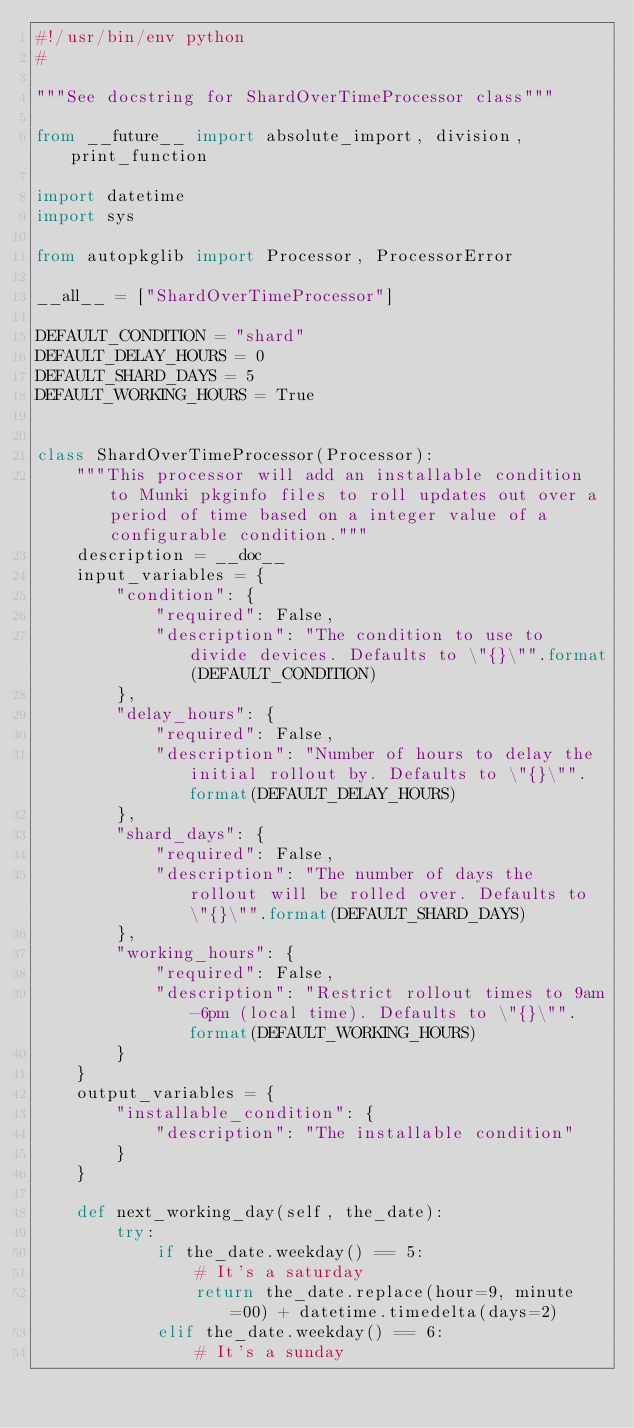Convert code to text. <code><loc_0><loc_0><loc_500><loc_500><_Python_>#!/usr/bin/env python
#

"""See docstring for ShardOverTimeProcessor class"""

from __future__ import absolute_import, division, print_function

import datetime
import sys

from autopkglib import Processor, ProcessorError

__all__ = ["ShardOverTimeProcessor"]

DEFAULT_CONDITION = "shard"
DEFAULT_DELAY_HOURS = 0
DEFAULT_SHARD_DAYS = 5
DEFAULT_WORKING_HOURS = True


class ShardOverTimeProcessor(Processor):
    """This processor will add an installable condition to Munki pkginfo files to roll updates out over a period of time based on a integer value of a configurable condition."""
    description = __doc__
    input_variables = {
        "condition": {
            "required": False,
            "description": "The condition to use to divide devices. Defaults to \"{}\"".format(DEFAULT_CONDITION)
        },
        "delay_hours": {
            "required": False,
            "description": "Number of hours to delay the initial rollout by. Defaults to \"{}\"".format(DEFAULT_DELAY_HOURS)
        },
        "shard_days": {
            "required": False,
            "description": "The number of days the rollout will be rolled over. Defaults to \"{}\"".format(DEFAULT_SHARD_DAYS)
        },
        "working_hours": {
            "required": False,
            "description": "Restrict rollout times to 9am-6pm (local time). Defaults to \"{}\"".format(DEFAULT_WORKING_HOURS)
        }
    }
    output_variables = {
        "installable_condition": {
            "description": "The installable condition"
        }
    }

    def next_working_day(self, the_date):
        try:
            if the_date.weekday() == 5:
                # It's a saturday
                return the_date.replace(hour=9, minute=00) + datetime.timedelta(days=2)
            elif the_date.weekday() == 6:
                # It's a sunday</code> 